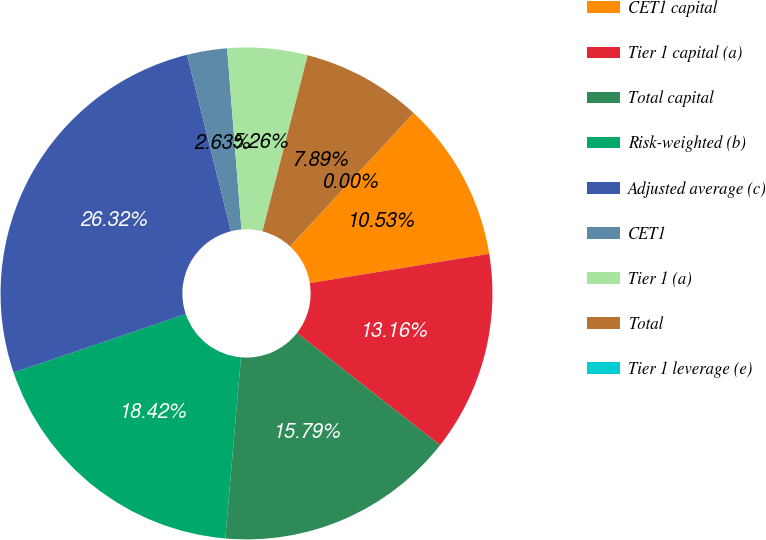<chart> <loc_0><loc_0><loc_500><loc_500><pie_chart><fcel>CET1 capital<fcel>Tier 1 capital (a)<fcel>Total capital<fcel>Risk-weighted (b)<fcel>Adjusted average (c)<fcel>CET1<fcel>Tier 1 (a)<fcel>Total<fcel>Tier 1 leverage (e)<nl><fcel>10.53%<fcel>13.16%<fcel>15.79%<fcel>18.42%<fcel>26.32%<fcel>2.63%<fcel>5.26%<fcel>7.89%<fcel>0.0%<nl></chart> 